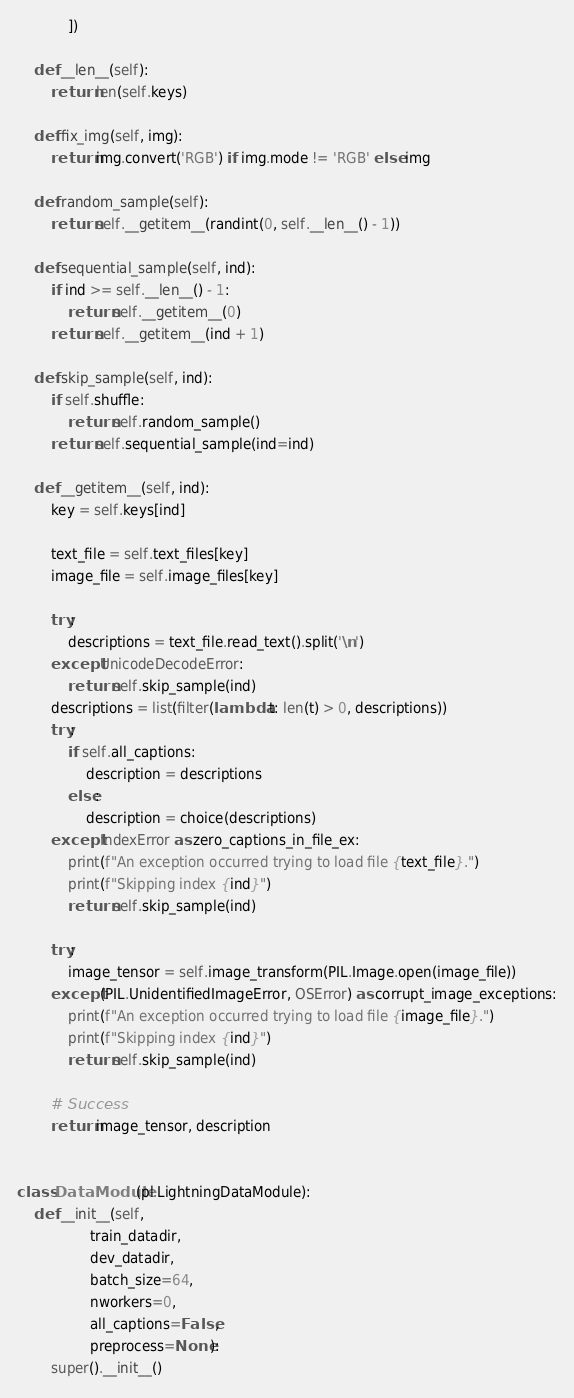<code> <loc_0><loc_0><loc_500><loc_500><_Python_>            ])

    def __len__(self):
        return len(self.keys)
    
    def fix_img(self, img):
        return img.convert('RGB') if img.mode != 'RGB' else img

    def random_sample(self):
        return self.__getitem__(randint(0, self.__len__() - 1))

    def sequential_sample(self, ind):
        if ind >= self.__len__() - 1:
            return self.__getitem__(0)
        return self.__getitem__(ind + 1)

    def skip_sample(self, ind):
        if self.shuffle:
            return self.random_sample()
        return self.sequential_sample(ind=ind)

    def __getitem__(self, ind):
        key = self.keys[ind]

        text_file = self.text_files[key]
        image_file = self.image_files[key]

        try:
            descriptions = text_file.read_text().split('\n')
        except UnicodeDecodeError:
            return self.skip_sample(ind)
        descriptions = list(filter(lambda t: len(t) > 0, descriptions))
        try:
            if self.all_captions:
                description = descriptions
            else:
                description = choice(descriptions)
        except IndexError as zero_captions_in_file_ex:
            print(f"An exception occurred trying to load file {text_file}.")
            print(f"Skipping index {ind}")
            return self.skip_sample(ind)

        try:
            image_tensor = self.image_transform(PIL.Image.open(image_file))
        except (PIL.UnidentifiedImageError, OSError) as corrupt_image_exceptions:
            print(f"An exception occurred trying to load file {image_file}.")
            print(f"Skipping index {ind}")
            return self.skip_sample(ind)

        # Success
        return image_tensor, description


class DataModule(pl.LightningDataModule):
    def __init__(self,
                 train_datadir,
                 dev_datadir,
                 batch_size=64,
                 nworkers=0,
                 all_captions=False,
                 preprocess=None):
        super().__init__()</code> 